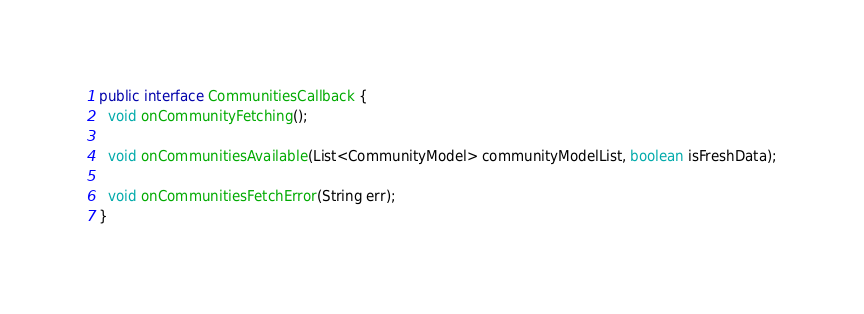Convert code to text. <code><loc_0><loc_0><loc_500><loc_500><_Java_>public interface CommunitiesCallback {
  void onCommunityFetching();

  void onCommunitiesAvailable(List<CommunityModel> communityModelList, boolean isFreshData);

  void onCommunitiesFetchError(String err);
}
</code> 